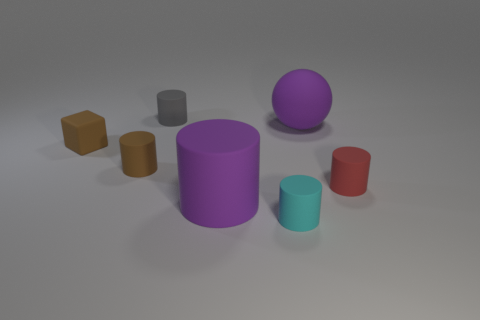What is the material of the gray thing that is the same shape as the red rubber object?
Keep it short and to the point. Rubber. The object that is both behind the cyan rubber cylinder and in front of the red thing has what shape?
Offer a terse response. Cylinder. Are there the same number of objects that are in front of the gray cylinder and small red rubber objects in front of the small red cylinder?
Offer a very short reply. No. Is there a small red cylinder made of the same material as the small brown cylinder?
Provide a short and direct response. Yes. Do the large purple thing that is behind the red cylinder and the tiny gray cylinder have the same material?
Provide a short and direct response. Yes. What is the size of the matte object that is both in front of the tiny red matte cylinder and behind the cyan matte cylinder?
Make the answer very short. Large. What is the color of the small cube?
Your answer should be very brief. Brown. How many gray rubber objects are there?
Your answer should be very brief. 1. How many other large matte spheres have the same color as the large ball?
Make the answer very short. 0. Is the shape of the purple rubber object that is behind the small matte cube the same as the rubber thing that is on the left side of the brown cylinder?
Provide a succinct answer. No. 